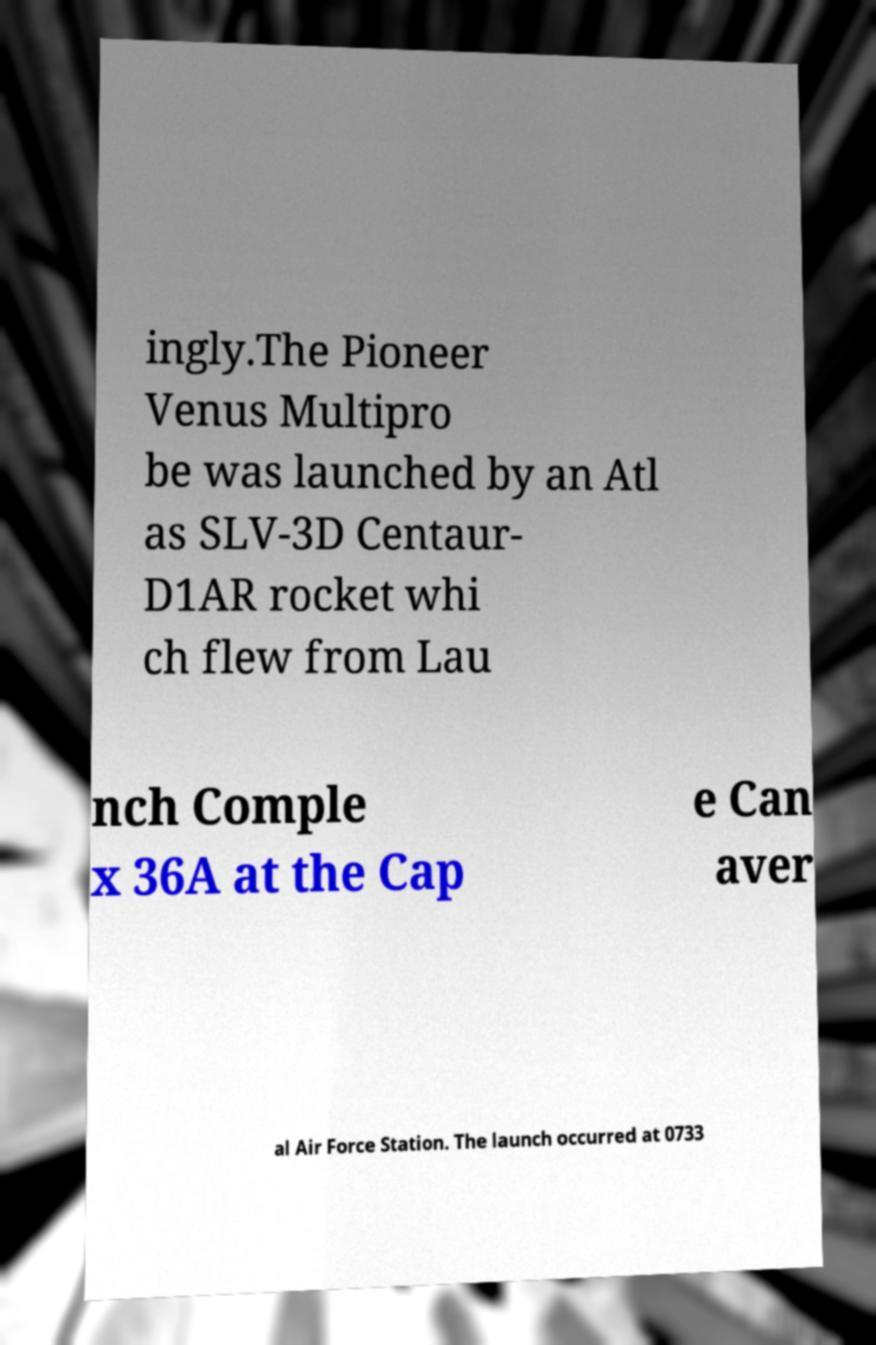Please read and relay the text visible in this image. What does it say? ingly.The Pioneer Venus Multipro be was launched by an Atl as SLV-3D Centaur- D1AR rocket whi ch flew from Lau nch Comple x 36A at the Cap e Can aver al Air Force Station. The launch occurred at 0733 